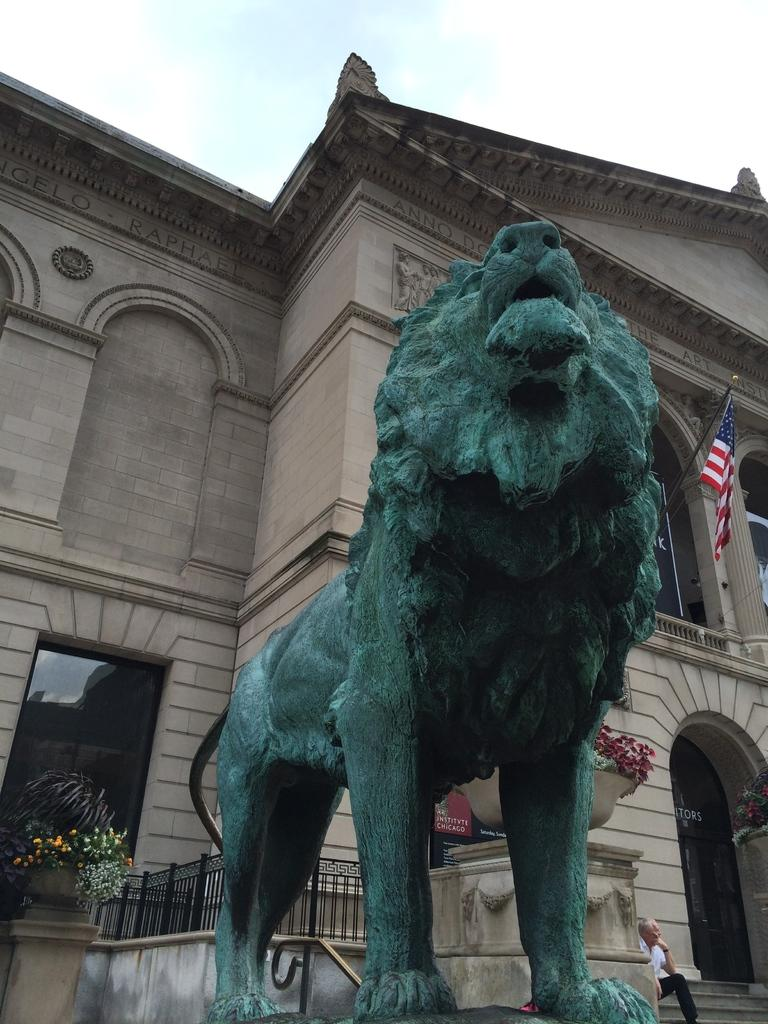What is the person in the image doing? There is a person sitting in the image. What other structures or objects can be seen in the image? There is a statue, a building, stairs, a fence, and plants visible in the image. What is the background of the image? The sky is visible in the image. Are there any symbols or emblems present in the image? Yes, there is a flag in the image. What type of spark can be seen coming from the jellyfish in the image? There is no jellyfish present in the image, so there cannot be any spark coming from it. 